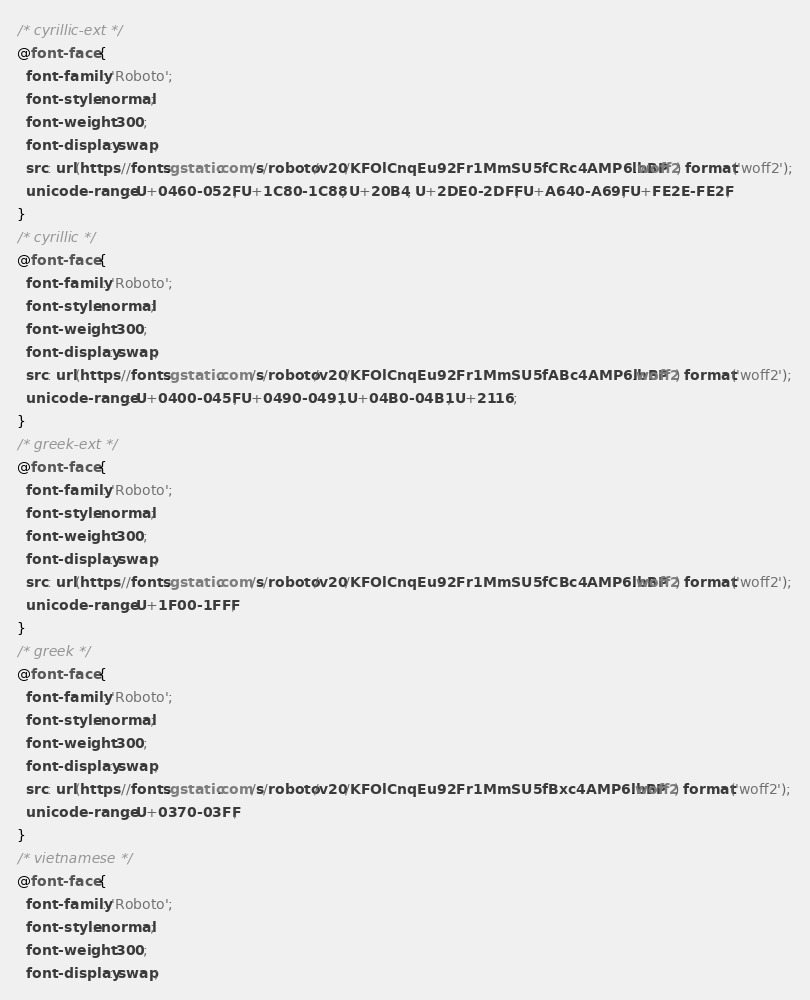Convert code to text. <code><loc_0><loc_0><loc_500><loc_500><_CSS_>/* cyrillic-ext */
@font-face {
  font-family: 'Roboto';
  font-style: normal;
  font-weight: 300;
  font-display: swap;
  src: url(https://fonts.gstatic.com/s/roboto/v20/KFOlCnqEu92Fr1MmSU5fCRc4AMP6lbBP.woff2) format('woff2');
  unicode-range: U+0460-052F, U+1C80-1C88, U+20B4, U+2DE0-2DFF, U+A640-A69F, U+FE2E-FE2F;
}
/* cyrillic */
@font-face {
  font-family: 'Roboto';
  font-style: normal;
  font-weight: 300;
  font-display: swap;
  src: url(https://fonts.gstatic.com/s/roboto/v20/KFOlCnqEu92Fr1MmSU5fABc4AMP6lbBP.woff2) format('woff2');
  unicode-range: U+0400-045F, U+0490-0491, U+04B0-04B1, U+2116;
}
/* greek-ext */
@font-face {
  font-family: 'Roboto';
  font-style: normal;
  font-weight: 300;
  font-display: swap;
  src: url(https://fonts.gstatic.com/s/roboto/v20/KFOlCnqEu92Fr1MmSU5fCBc4AMP6lbBP.woff2) format('woff2');
  unicode-range: U+1F00-1FFF;
}
/* greek */
@font-face {
  font-family: 'Roboto';
  font-style: normal;
  font-weight: 300;
  font-display: swap;
  src: url(https://fonts.gstatic.com/s/roboto/v20/KFOlCnqEu92Fr1MmSU5fBxc4AMP6lbBP.woff2) format('woff2');
  unicode-range: U+0370-03FF;
}
/* vietnamese */
@font-face {
  font-family: 'Roboto';
  font-style: normal;
  font-weight: 300;
  font-display: swap;</code> 